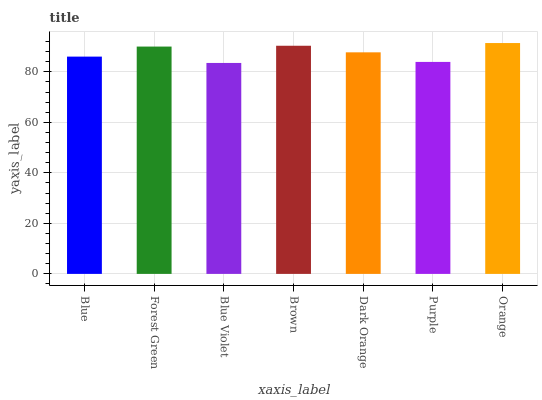Is Blue Violet the minimum?
Answer yes or no. Yes. Is Orange the maximum?
Answer yes or no. Yes. Is Forest Green the minimum?
Answer yes or no. No. Is Forest Green the maximum?
Answer yes or no. No. Is Forest Green greater than Blue?
Answer yes or no. Yes. Is Blue less than Forest Green?
Answer yes or no. Yes. Is Blue greater than Forest Green?
Answer yes or no. No. Is Forest Green less than Blue?
Answer yes or no. No. Is Dark Orange the high median?
Answer yes or no. Yes. Is Dark Orange the low median?
Answer yes or no. Yes. Is Orange the high median?
Answer yes or no. No. Is Blue the low median?
Answer yes or no. No. 